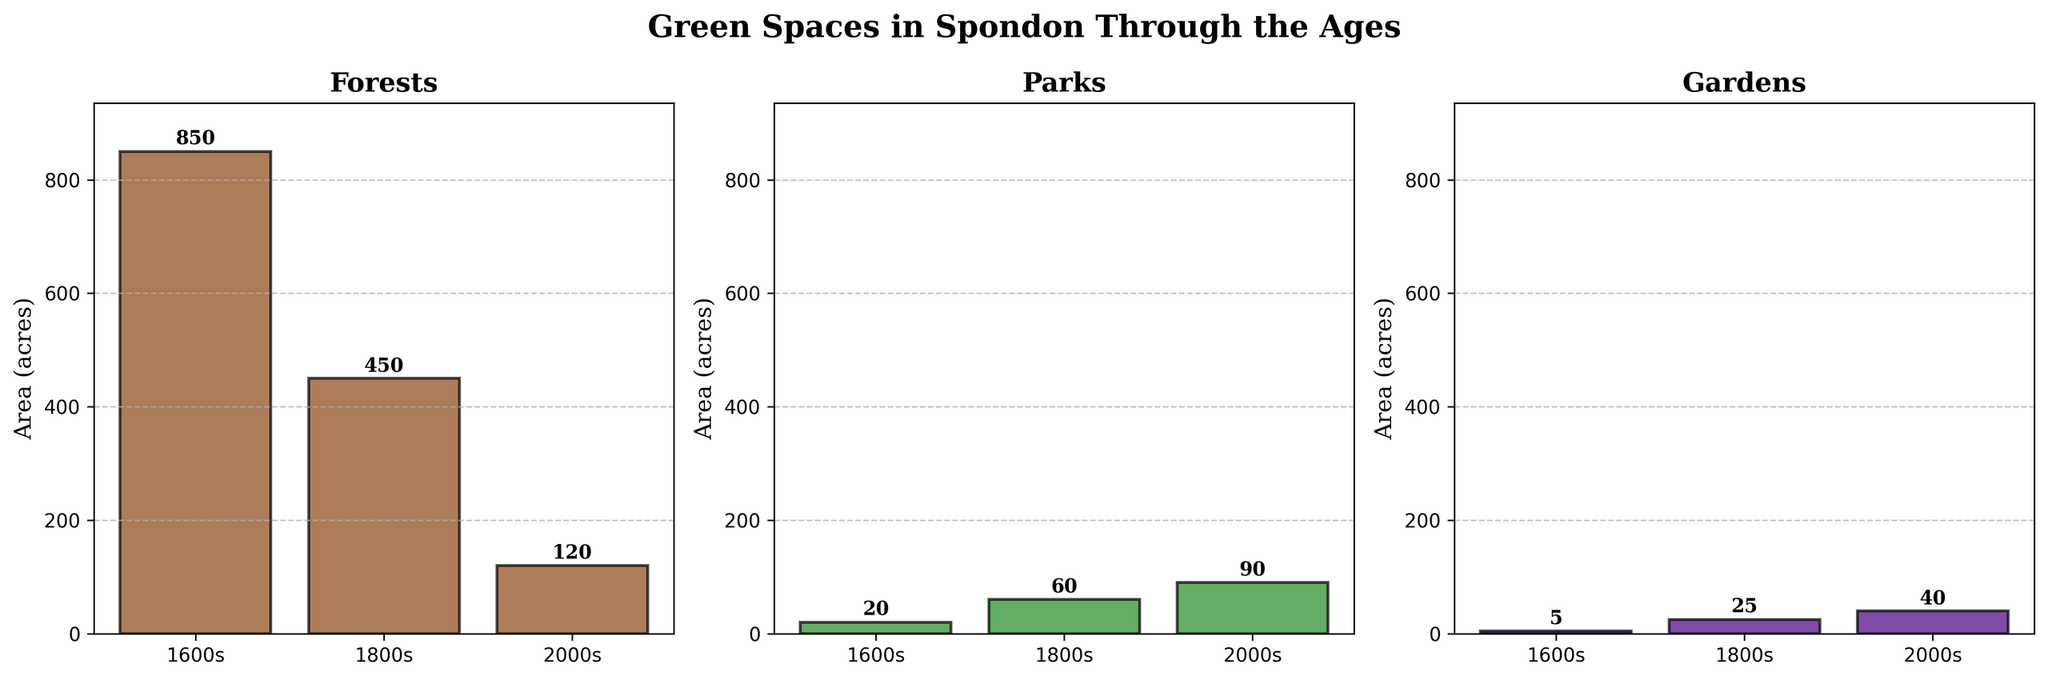what is the title of the figure? The title of the figure is located at the top of the plot. It reads "Green Spaces in Spondon Through the Ages".
Answer: Green Spaces in Spondon Through the Ages Which type of green space had the largest area in the 1600s? By looking at the bars for each type of green space for the 1600s, the tallest bar corresponds to forests.
Answer: Forests How does the area of parks in the 1800s compare to the area of gardens in the 2000s? In the 1800s, the park area is represented by a bar with a value of 60 acres. In the 2000s, the garden area is represented by a bar with a value of 40 acres. Thus, the park area in the 1800s is larger than the garden area in the 2000s.
Answer: Parks in the 1800s are larger What is the reduction in forest area from the 1600s to the 2000s? To find this, take the forest area from the 1600s (850 acres) and subtract the forest area in the 2000s (120 acres). This is calculated as 850 - 120.
Answer: 730 acres How did the area of gardens change from the 1600s to the 2000s? Look at the bar heights for gardens in the 1600s, which is 5 acres, and compare it to the height in the 2000s, which is 40 acres. The area increased.
Answer: Increased by 35 acres Which green space type in the 2000s occupies the smallest area? By examining the heights of the bars for all types in the 2000s, the shortest bar corresponds to forests with an area of 120 acres.
Answer: Forests By how much did the area of parks increase from the 1600s to the 1800s? The area of parks in the 1600s is 20 acres and in the 1800s it is 60 acres. Subtract 20 from 60 to find the increase.
Answer: 40 acres Compare the total area of all green spaces in the 1600s to the 2000s. Sum the areas of all types of green spaces for each period. For the 1600s: 850 (forests) + 20 (parks) + 5 (gardens) = 875 acres. For the 2000s: 120 (forests) + 90 (parks) + 40 (gardens) = 250 acres.
Answer: 875 acres (1600s) vs 250 acres (2000s) In which time period did forests have a significant reduction compared to previous periods? Throughout the time periods, forests show a large reduction from 850 acres (1600s) to 450 acres (1800s), then further down to 120 acres (2000s). Both reductions are significant, but the largest reduction occurs from the 1600s to the 1800s.
Answer: 1600s to 1800s 